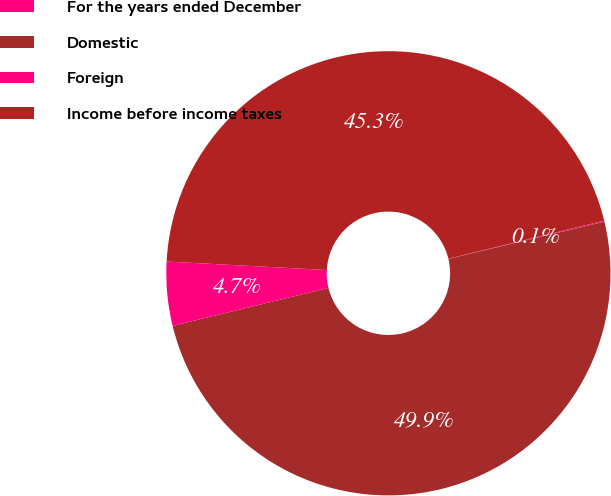<chart> <loc_0><loc_0><loc_500><loc_500><pie_chart><fcel>For the years ended December<fcel>Domestic<fcel>Foreign<fcel>Income before income taxes<nl><fcel>0.07%<fcel>49.93%<fcel>4.65%<fcel>45.35%<nl></chart> 